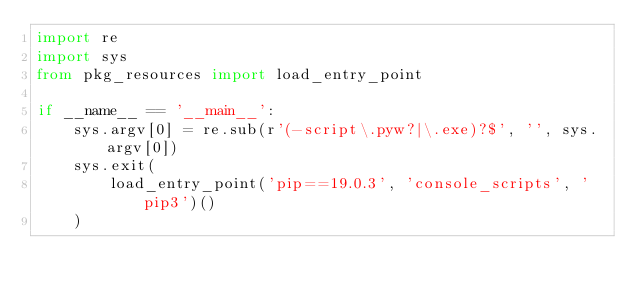Convert code to text. <code><loc_0><loc_0><loc_500><loc_500><_Python_>import re
import sys
from pkg_resources import load_entry_point

if __name__ == '__main__':
    sys.argv[0] = re.sub(r'(-script\.pyw?|\.exe)?$', '', sys.argv[0])
    sys.exit(
        load_entry_point('pip==19.0.3', 'console_scripts', 'pip3')()
    )
</code> 